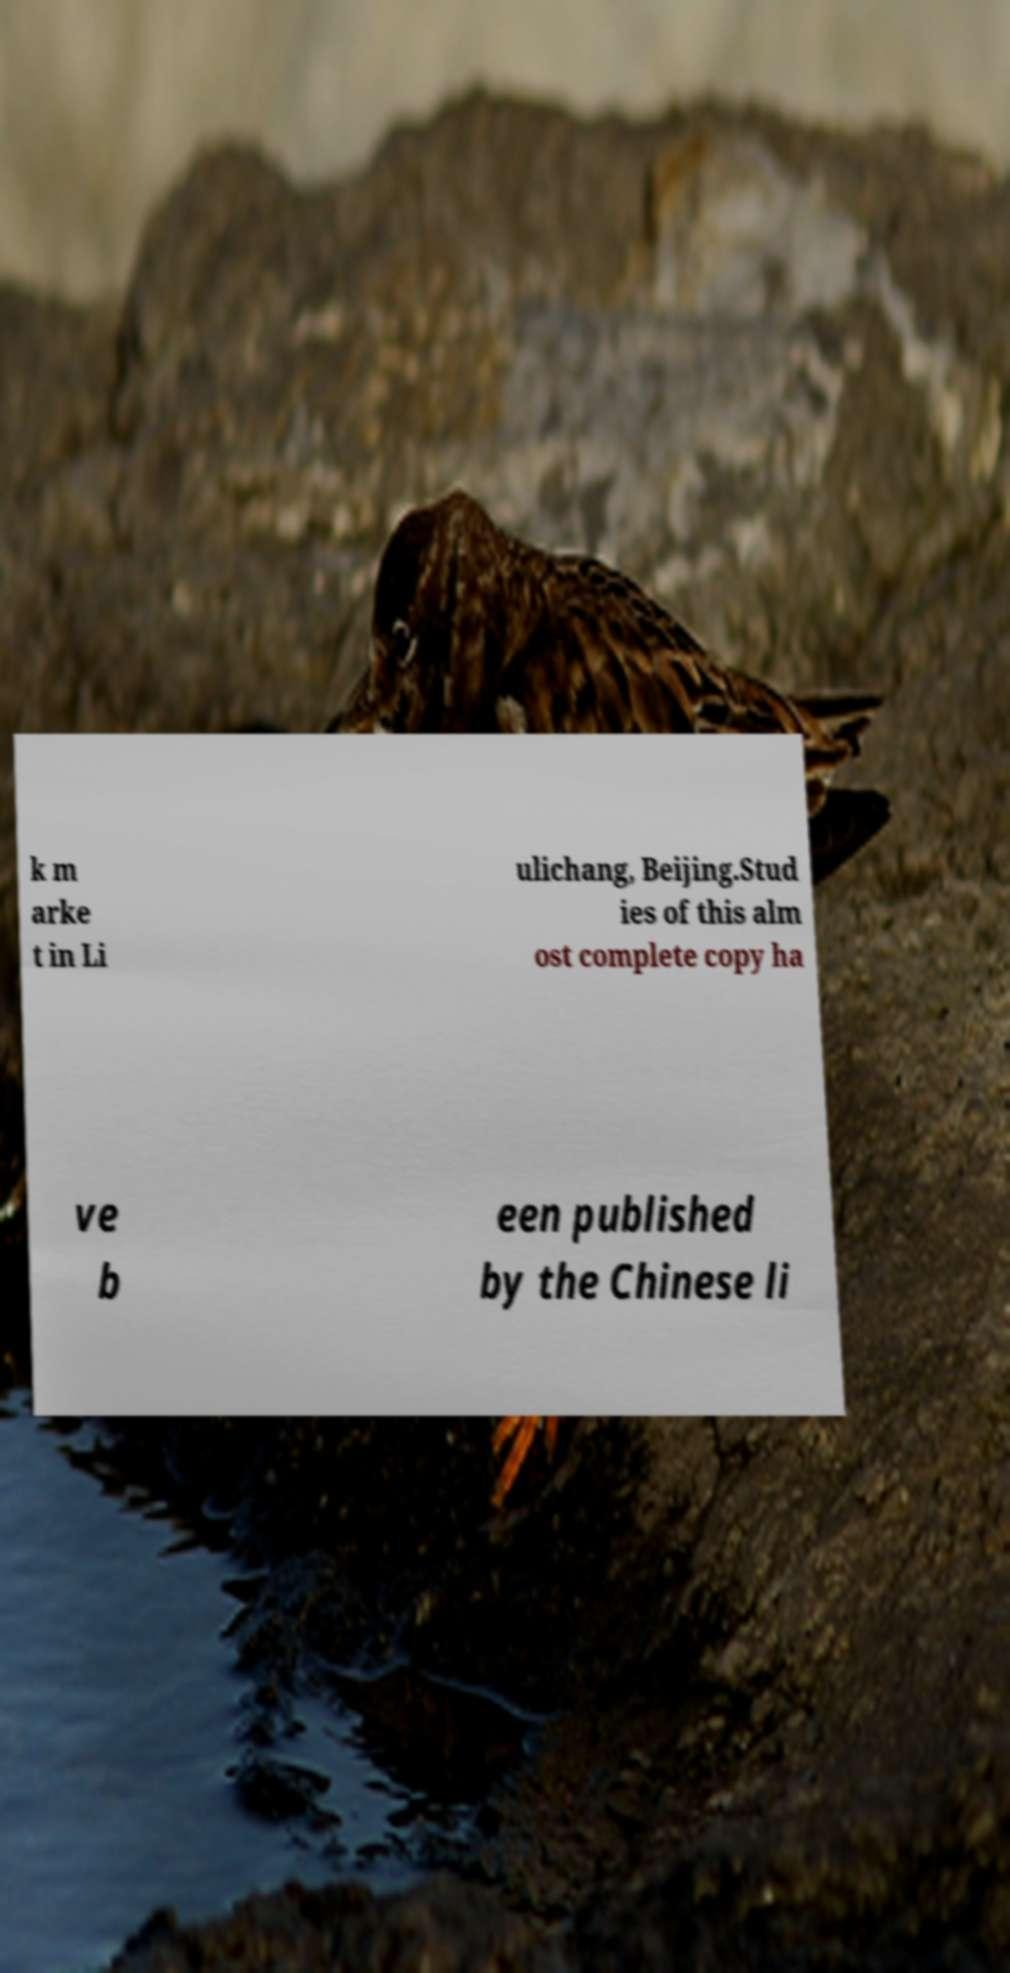Could you extract and type out the text from this image? k m arke t in Li ulichang, Beijing.Stud ies of this alm ost complete copy ha ve b een published by the Chinese li 